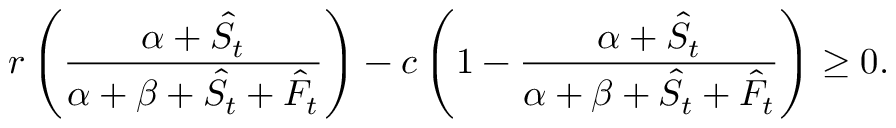Convert formula to latex. <formula><loc_0><loc_0><loc_500><loc_500>r \left ( \frac { \alpha + \hat { S } _ { t } } { \alpha + \beta + \hat { S } _ { t } + \hat { F } _ { t } } \right ) - c \left ( 1 - \frac { \alpha + \hat { S } _ { t } } { \alpha + \beta + \hat { S } _ { t } + \hat { F } _ { t } } \right ) \geq 0 .</formula> 